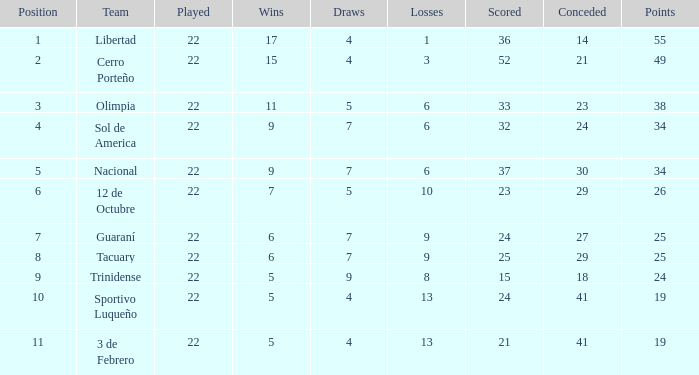What was the point value achieved by team 3 de febrero when they scored 19 points? 21.0. 